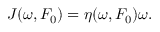Convert formula to latex. <formula><loc_0><loc_0><loc_500><loc_500>J ( \omega , F _ { 0 } ) = \eta ( \omega , F _ { 0 } ) \omega .</formula> 